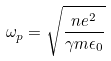<formula> <loc_0><loc_0><loc_500><loc_500>\omega _ { p } = \sqrt { \frac { n e ^ { 2 } } { \gamma m \epsilon _ { 0 } } }</formula> 